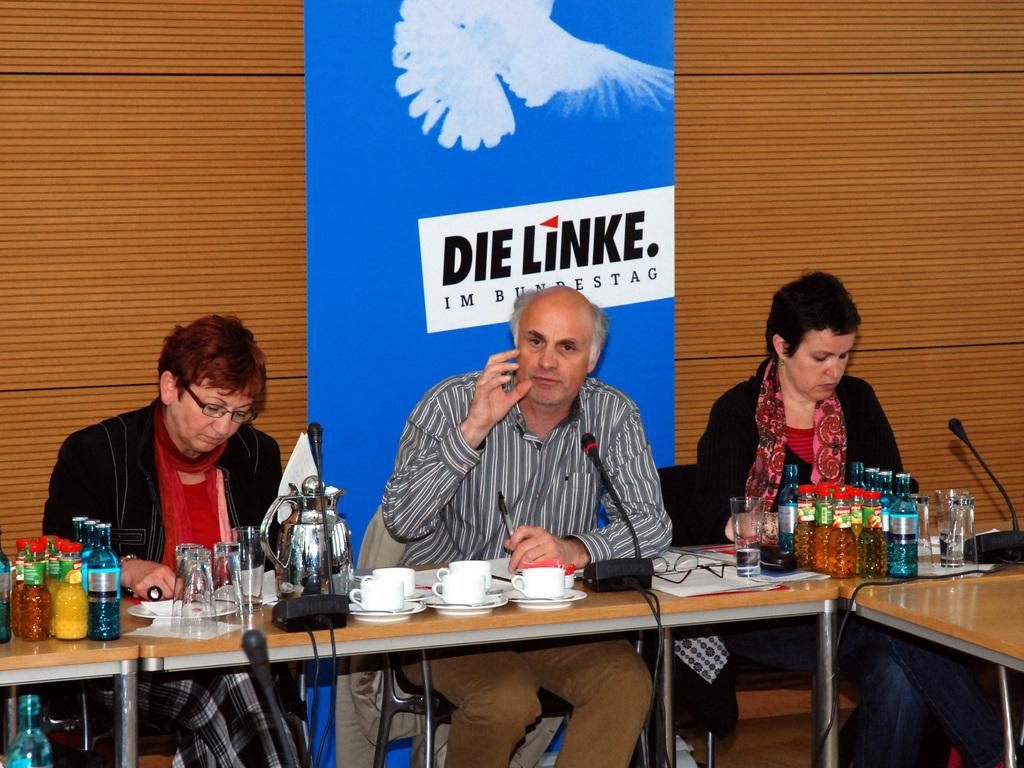What are the persons in the image doing? The persons in the image are sitting on chairs. What objects can be seen on the table in the image? There are bottles, a mic, a jar, cups, papers, spectacles, and glasses on the table. What is the color of the banner in the image? The banner in the image is blue. What type of polish is being applied to the wall in the image? There is no wall or polish present in the image. What kind of hall is visible in the image? There is no hall visible in the image. 